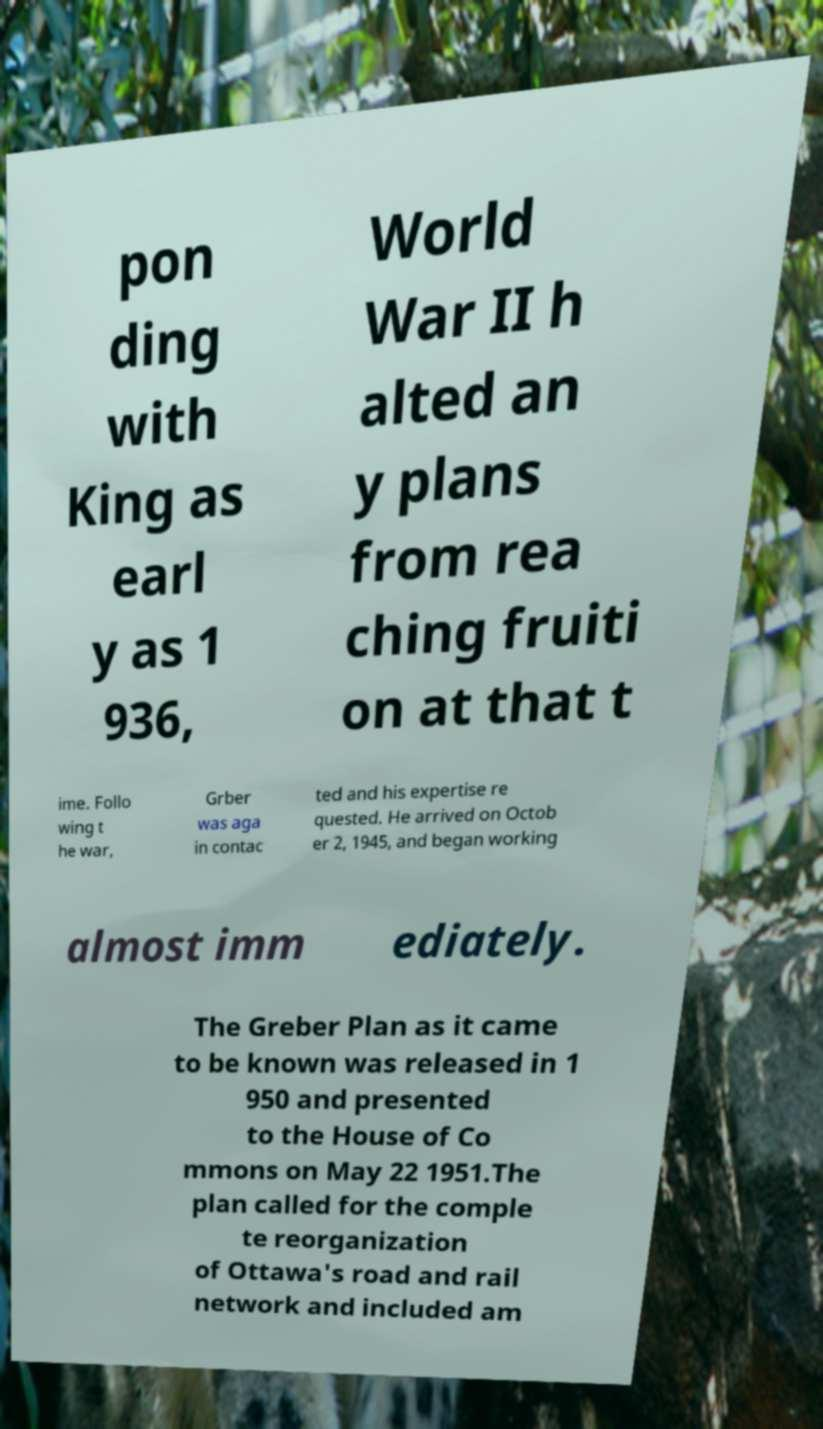Can you read and provide the text displayed in the image?This photo seems to have some interesting text. Can you extract and type it out for me? pon ding with King as earl y as 1 936, World War II h alted an y plans from rea ching fruiti on at that t ime. Follo wing t he war, Grber was aga in contac ted and his expertise re quested. He arrived on Octob er 2, 1945, and began working almost imm ediately. The Greber Plan as it came to be known was released in 1 950 and presented to the House of Co mmons on May 22 1951.The plan called for the comple te reorganization of Ottawa's road and rail network and included am 